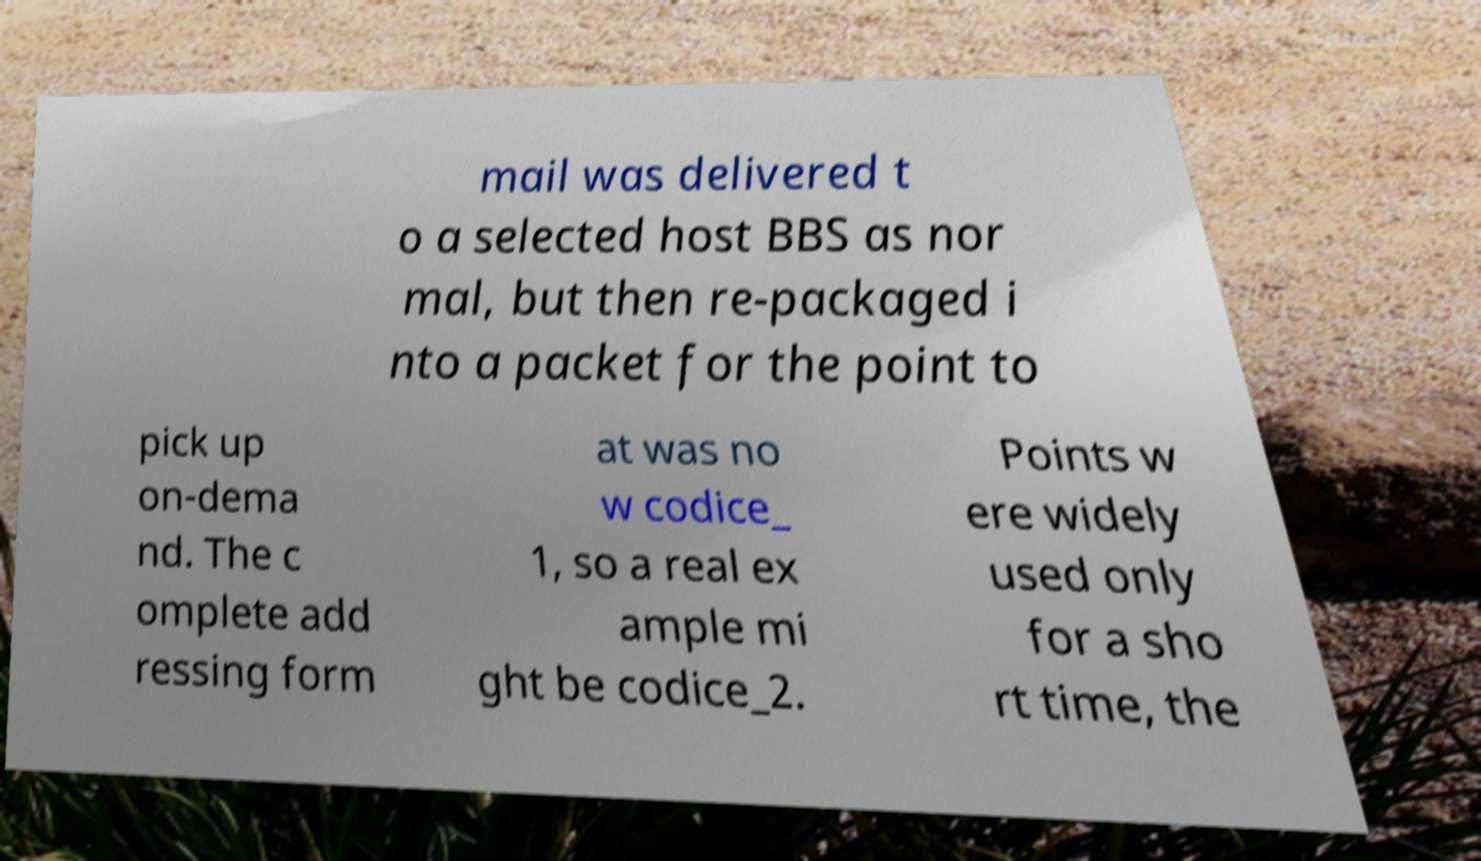Could you assist in decoding the text presented in this image and type it out clearly? mail was delivered t o a selected host BBS as nor mal, but then re-packaged i nto a packet for the point to pick up on-dema nd. The c omplete add ressing form at was no w codice_ 1, so a real ex ample mi ght be codice_2. Points w ere widely used only for a sho rt time, the 